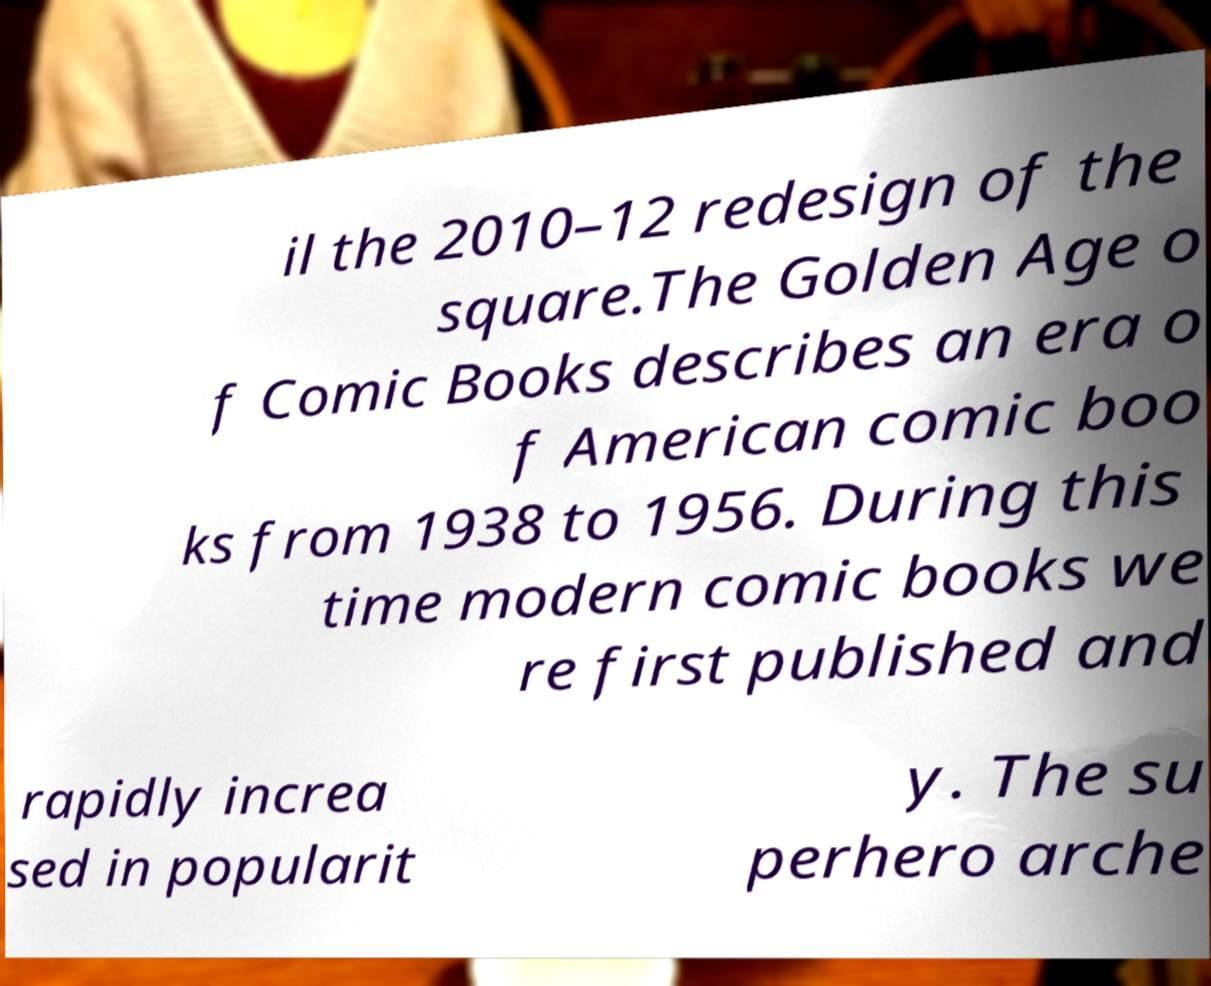For documentation purposes, I need the text within this image transcribed. Could you provide that? il the 2010–12 redesign of the square.The Golden Age o f Comic Books describes an era o f American comic boo ks from 1938 to 1956. During this time modern comic books we re first published and rapidly increa sed in popularit y. The su perhero arche 